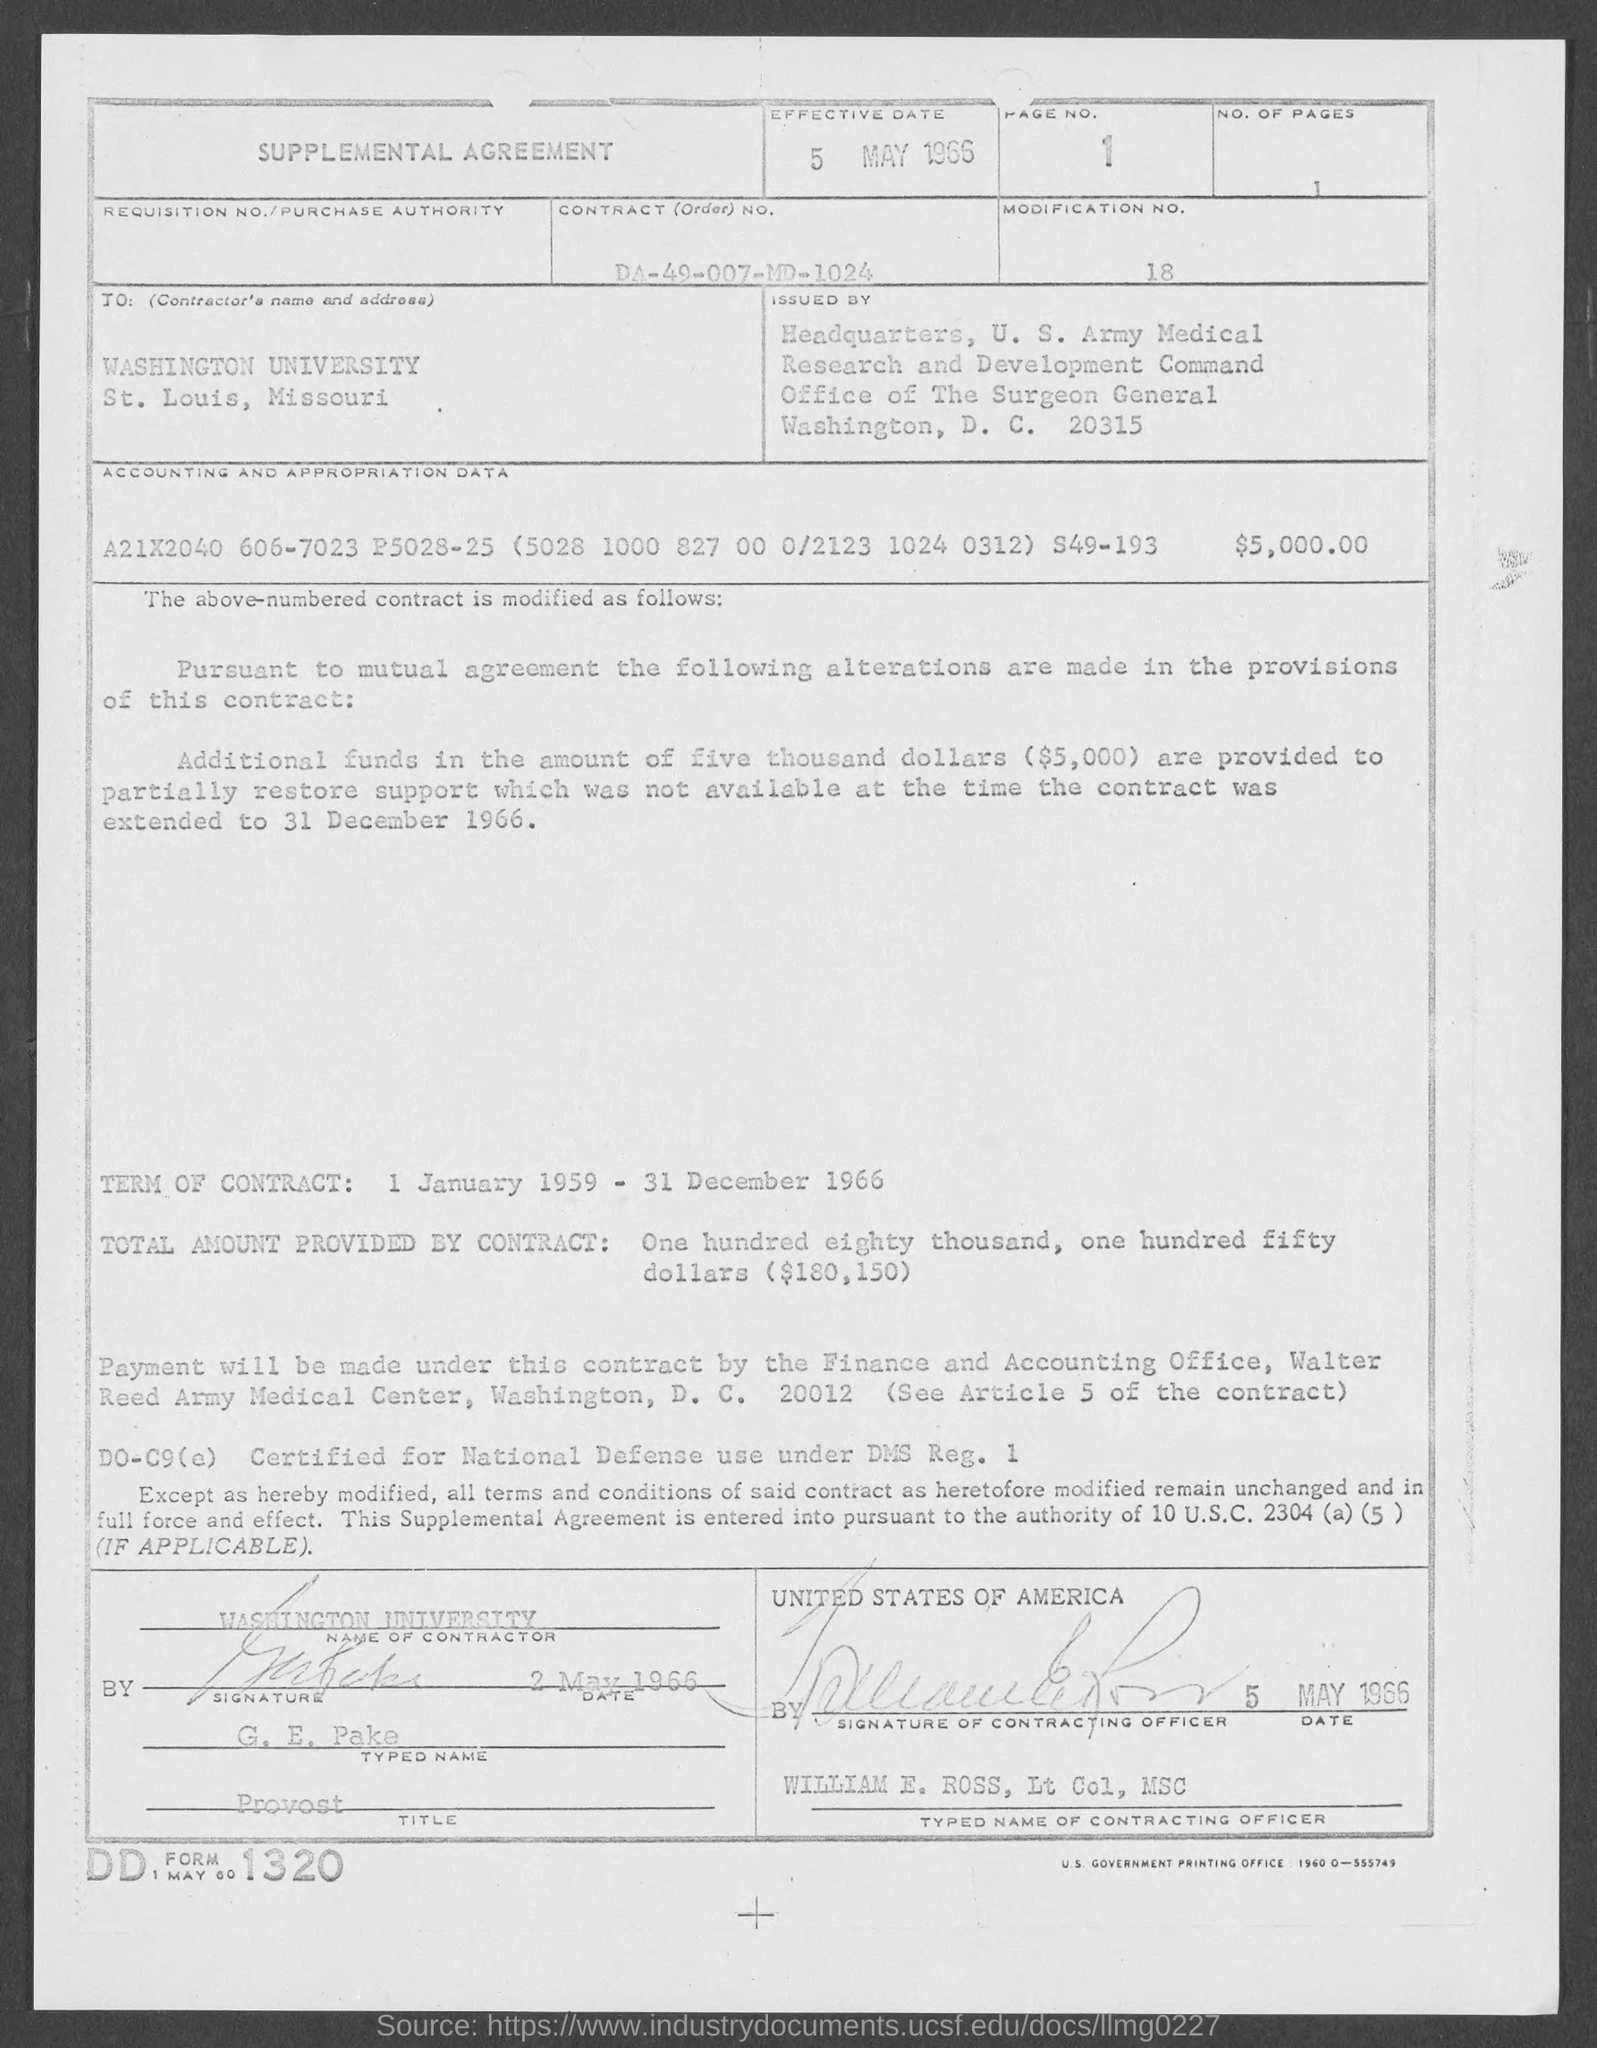What is the Title of the Document?
Offer a very short reply. Supplemental Agreement. What is the Effective Date?
Your response must be concise. 5 MAY 1966. What is the Contract (order) No.?
Your response must be concise. DA-49-007-MD-1024. What is the Modification No.?
Make the answer very short. 18. What is the Name of Contractor?
Ensure brevity in your answer.  WASHINGTON UNIVERSITY. What is the Typed Name?
Keep it short and to the point. G. E. Pake. What is the Typed Name of Contracting Officer?
Your answer should be compact. WILLIAM E. ROSS. 